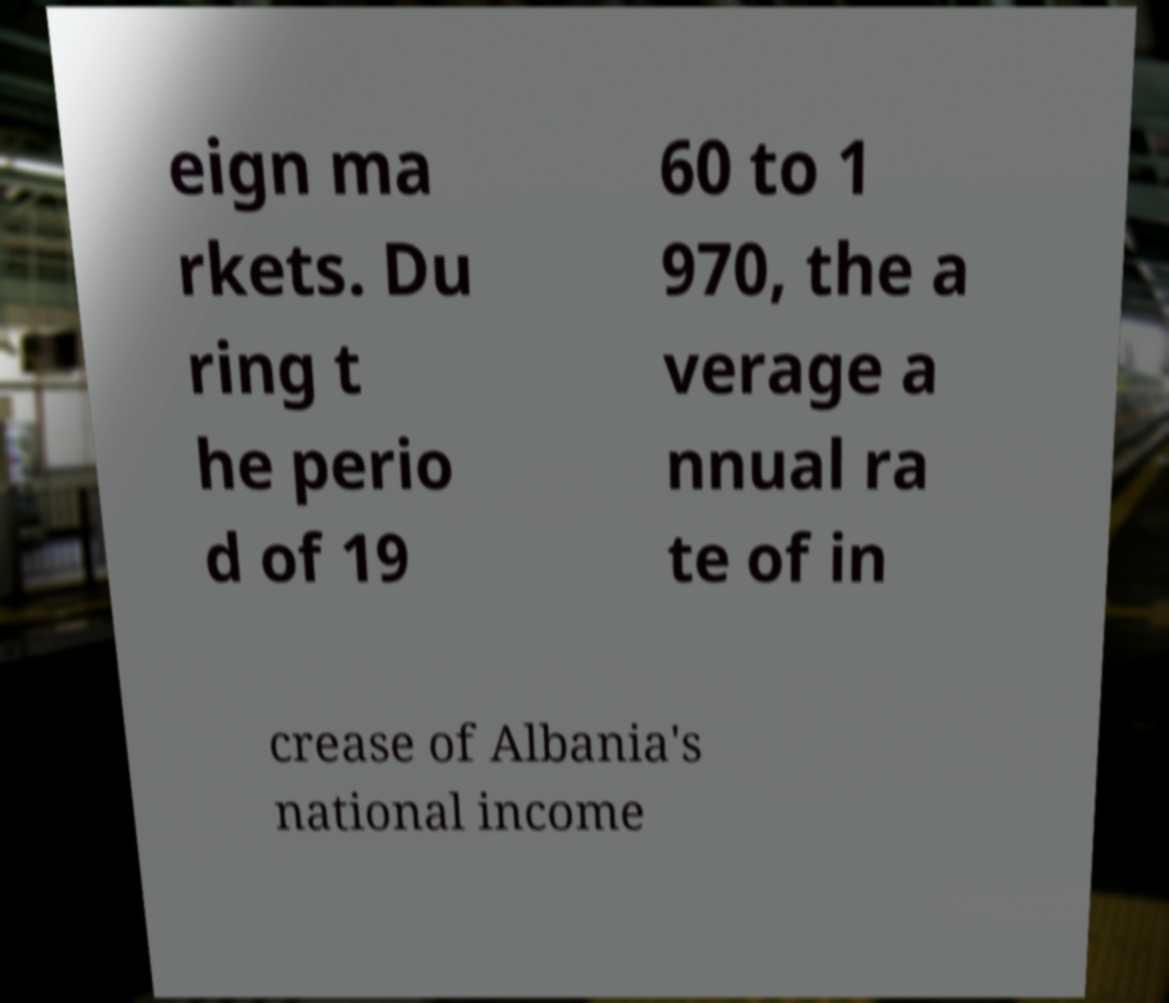What messages or text are displayed in this image? I need them in a readable, typed format. eign ma rkets. Du ring t he perio d of 19 60 to 1 970, the a verage a nnual ra te of in crease of Albania's national income 